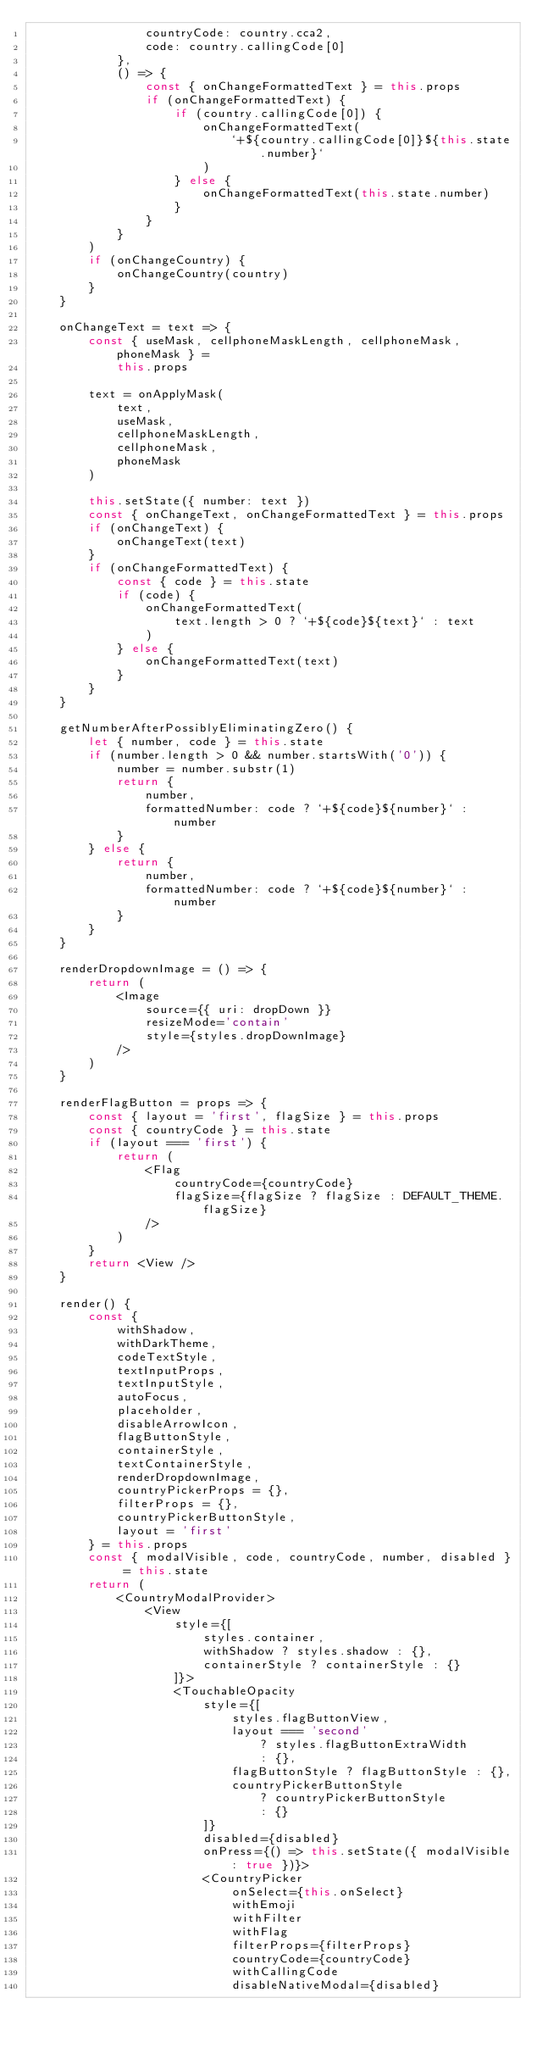<code> <loc_0><loc_0><loc_500><loc_500><_JavaScript_>                countryCode: country.cca2,
                code: country.callingCode[0]
            },
            () => {
                const { onChangeFormattedText } = this.props
                if (onChangeFormattedText) {
                    if (country.callingCode[0]) {
                        onChangeFormattedText(
                            `+${country.callingCode[0]}${this.state.number}`
                        )
                    } else {
                        onChangeFormattedText(this.state.number)
                    }
                }
            }
        )
        if (onChangeCountry) {
            onChangeCountry(country)
        }
    }

    onChangeText = text => {
        const { useMask, cellphoneMaskLength, cellphoneMask, phoneMask } =
            this.props

        text = onApplyMask(
            text,
            useMask,
            cellphoneMaskLength,
            cellphoneMask,
            phoneMask
        )

        this.setState({ number: text })
        const { onChangeText, onChangeFormattedText } = this.props
        if (onChangeText) {
            onChangeText(text)
        }
        if (onChangeFormattedText) {
            const { code } = this.state
            if (code) {
                onChangeFormattedText(
                    text.length > 0 ? `+${code}${text}` : text
                )
            } else {
                onChangeFormattedText(text)
            }
        }
    }

    getNumberAfterPossiblyEliminatingZero() {
        let { number, code } = this.state
        if (number.length > 0 && number.startsWith('0')) {
            number = number.substr(1)
            return {
                number,
                formattedNumber: code ? `+${code}${number}` : number
            }
        } else {
            return {
                number,
                formattedNumber: code ? `+${code}${number}` : number
            }
        }
    }

    renderDropdownImage = () => {
        return (
            <Image
                source={{ uri: dropDown }}
                resizeMode='contain'
                style={styles.dropDownImage}
            />
        )
    }

    renderFlagButton = props => {
        const { layout = 'first', flagSize } = this.props
        const { countryCode } = this.state
        if (layout === 'first') {
            return (
                <Flag
                    countryCode={countryCode}
                    flagSize={flagSize ? flagSize : DEFAULT_THEME.flagSize}
                />
            )
        }
        return <View />
    }

    render() {
        const {
            withShadow,
            withDarkTheme,
            codeTextStyle,
            textInputProps,
            textInputStyle,
            autoFocus,
            placeholder,
            disableArrowIcon,
            flagButtonStyle,
            containerStyle,
            textContainerStyle,
            renderDropdownImage,
            countryPickerProps = {},
            filterProps = {},
            countryPickerButtonStyle,
            layout = 'first'
        } = this.props
        const { modalVisible, code, countryCode, number, disabled } = this.state
        return (
            <CountryModalProvider>
                <View
                    style={[
                        styles.container,
                        withShadow ? styles.shadow : {},
                        containerStyle ? containerStyle : {}
                    ]}>
                    <TouchableOpacity
                        style={[
                            styles.flagButtonView,
                            layout === 'second'
                                ? styles.flagButtonExtraWidth
                                : {},
                            flagButtonStyle ? flagButtonStyle : {},
                            countryPickerButtonStyle
                                ? countryPickerButtonStyle
                                : {}
                        ]}
                        disabled={disabled}
                        onPress={() => this.setState({ modalVisible: true })}>
                        <CountryPicker
                            onSelect={this.onSelect}
                            withEmoji
                            withFilter
                            withFlag
                            filterProps={filterProps}
                            countryCode={countryCode}
                            withCallingCode
                            disableNativeModal={disabled}</code> 